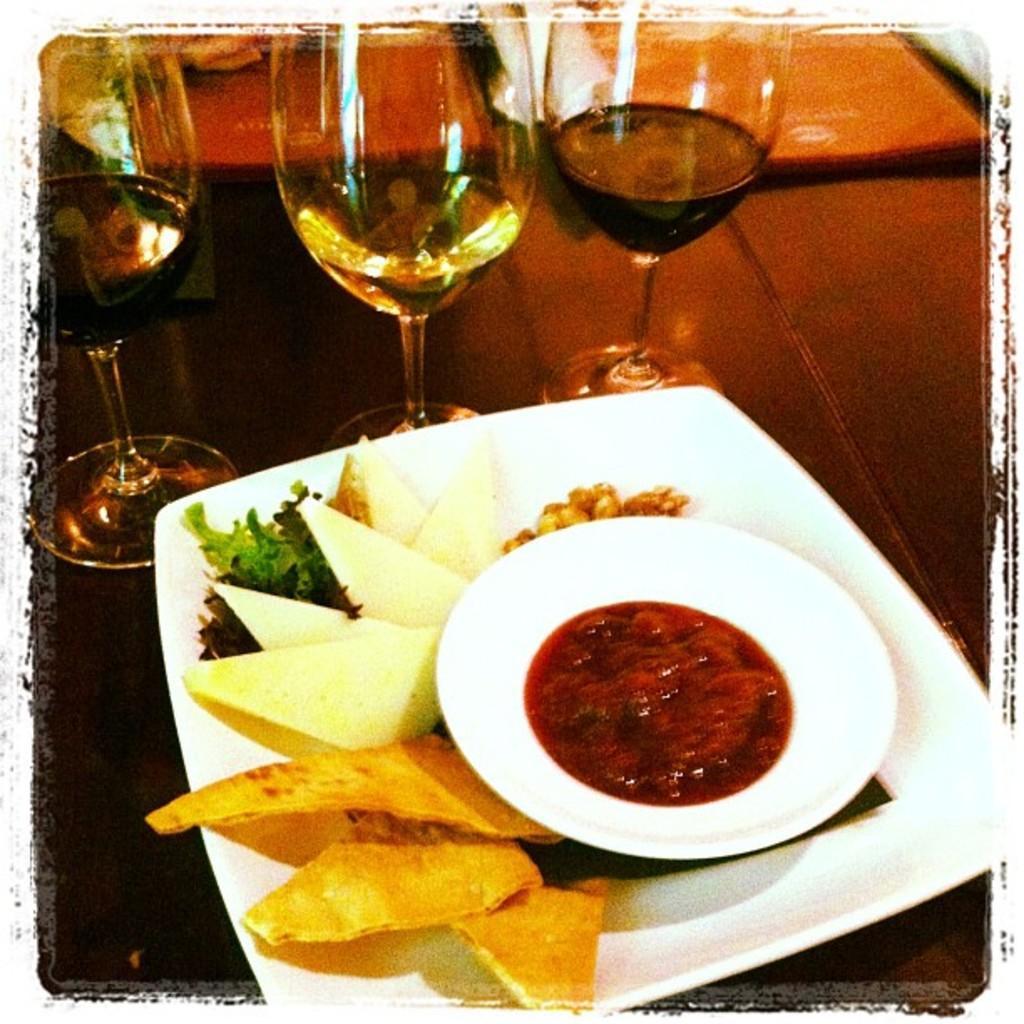In one or two sentences, can you explain what this image depicts? In this image we can see two plates containing food and glasses are placed on the table. In the background, we can two books. 